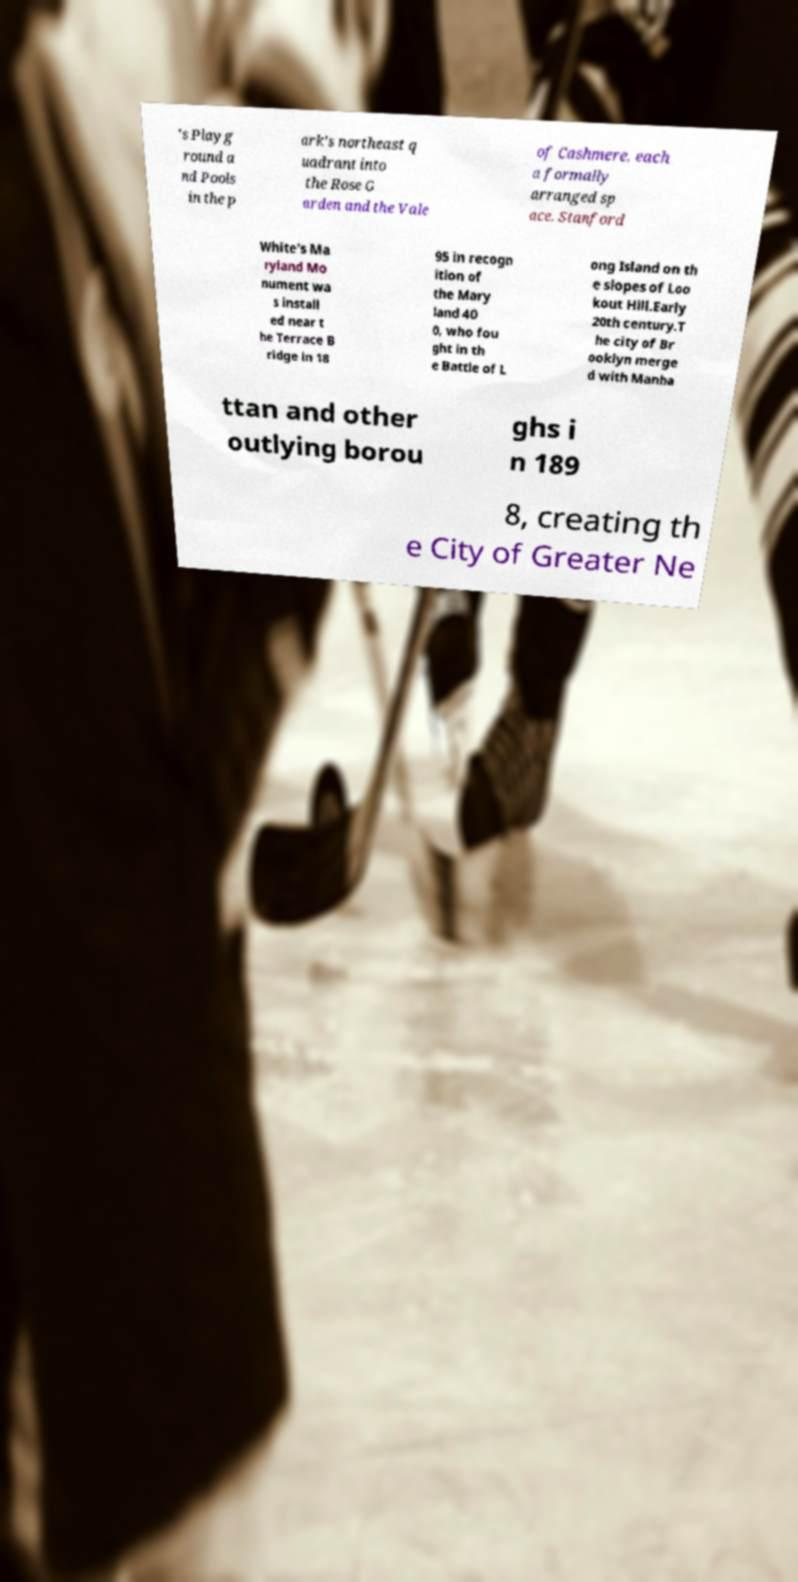There's text embedded in this image that I need extracted. Can you transcribe it verbatim? 's Playg round a nd Pools in the p ark's northeast q uadrant into the Rose G arden and the Vale of Cashmere, each a formally arranged sp ace. Stanford White's Ma ryland Mo nument wa s install ed near t he Terrace B ridge in 18 95 in recogn ition of the Mary land 40 0, who fou ght in th e Battle of L ong Island on th e slopes of Loo kout Hill.Early 20th century.T he city of Br ooklyn merge d with Manha ttan and other outlying borou ghs i n 189 8, creating th e City of Greater Ne 